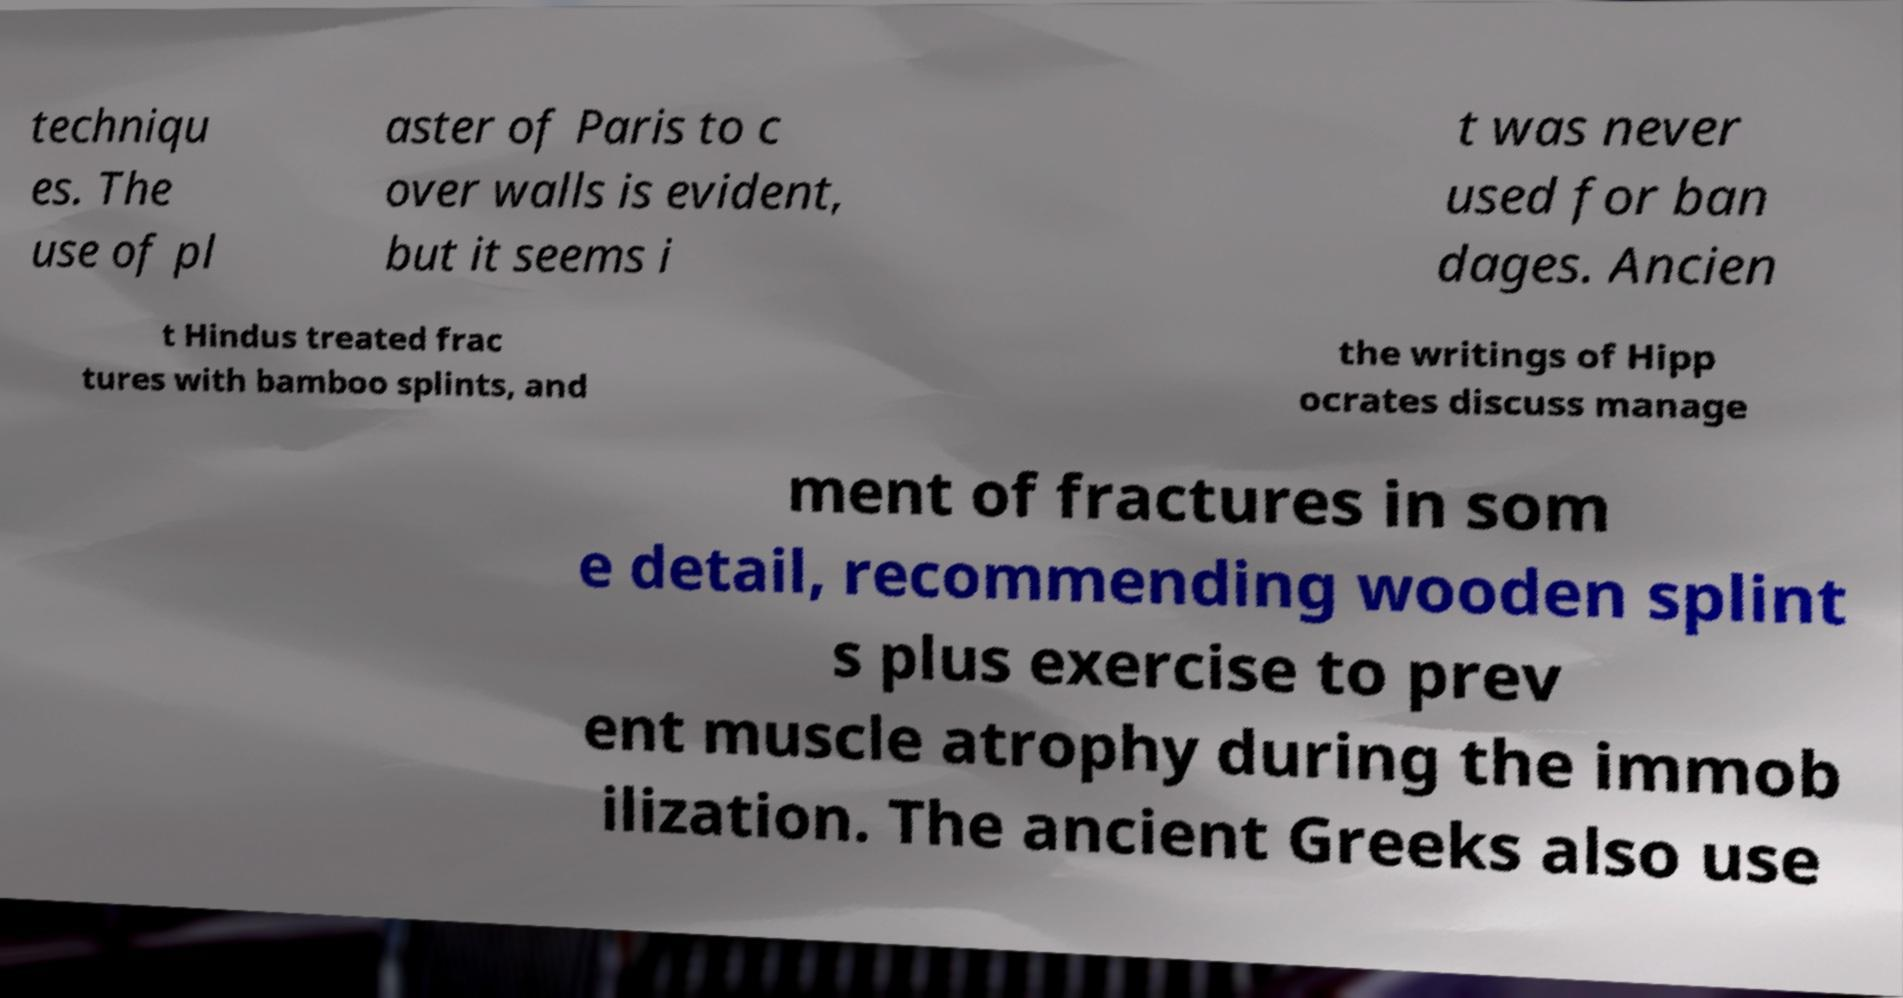Can you accurately transcribe the text from the provided image for me? techniqu es. The use of pl aster of Paris to c over walls is evident, but it seems i t was never used for ban dages. Ancien t Hindus treated frac tures with bamboo splints, and the writings of Hipp ocrates discuss manage ment of fractures in som e detail, recommending wooden splint s plus exercise to prev ent muscle atrophy during the immob ilization. The ancient Greeks also use 